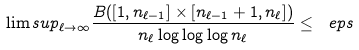Convert formula to latex. <formula><loc_0><loc_0><loc_500><loc_500>\lim s u p _ { \ell \to \infty } \frac { B ( [ 1 , n _ { \ell - 1 } ] \times [ n _ { \ell - 1 } + 1 , n _ { \ell } ] ) } { n _ { \ell } \log \log \log n _ { \ell } } \leq \ e p s</formula> 